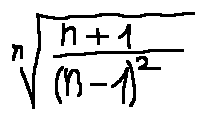<formula> <loc_0><loc_0><loc_500><loc_500>\sqrt { [ } n ] { \frac { n + 1 } { ( n - 1 ) ^ { 2 } } }</formula> 